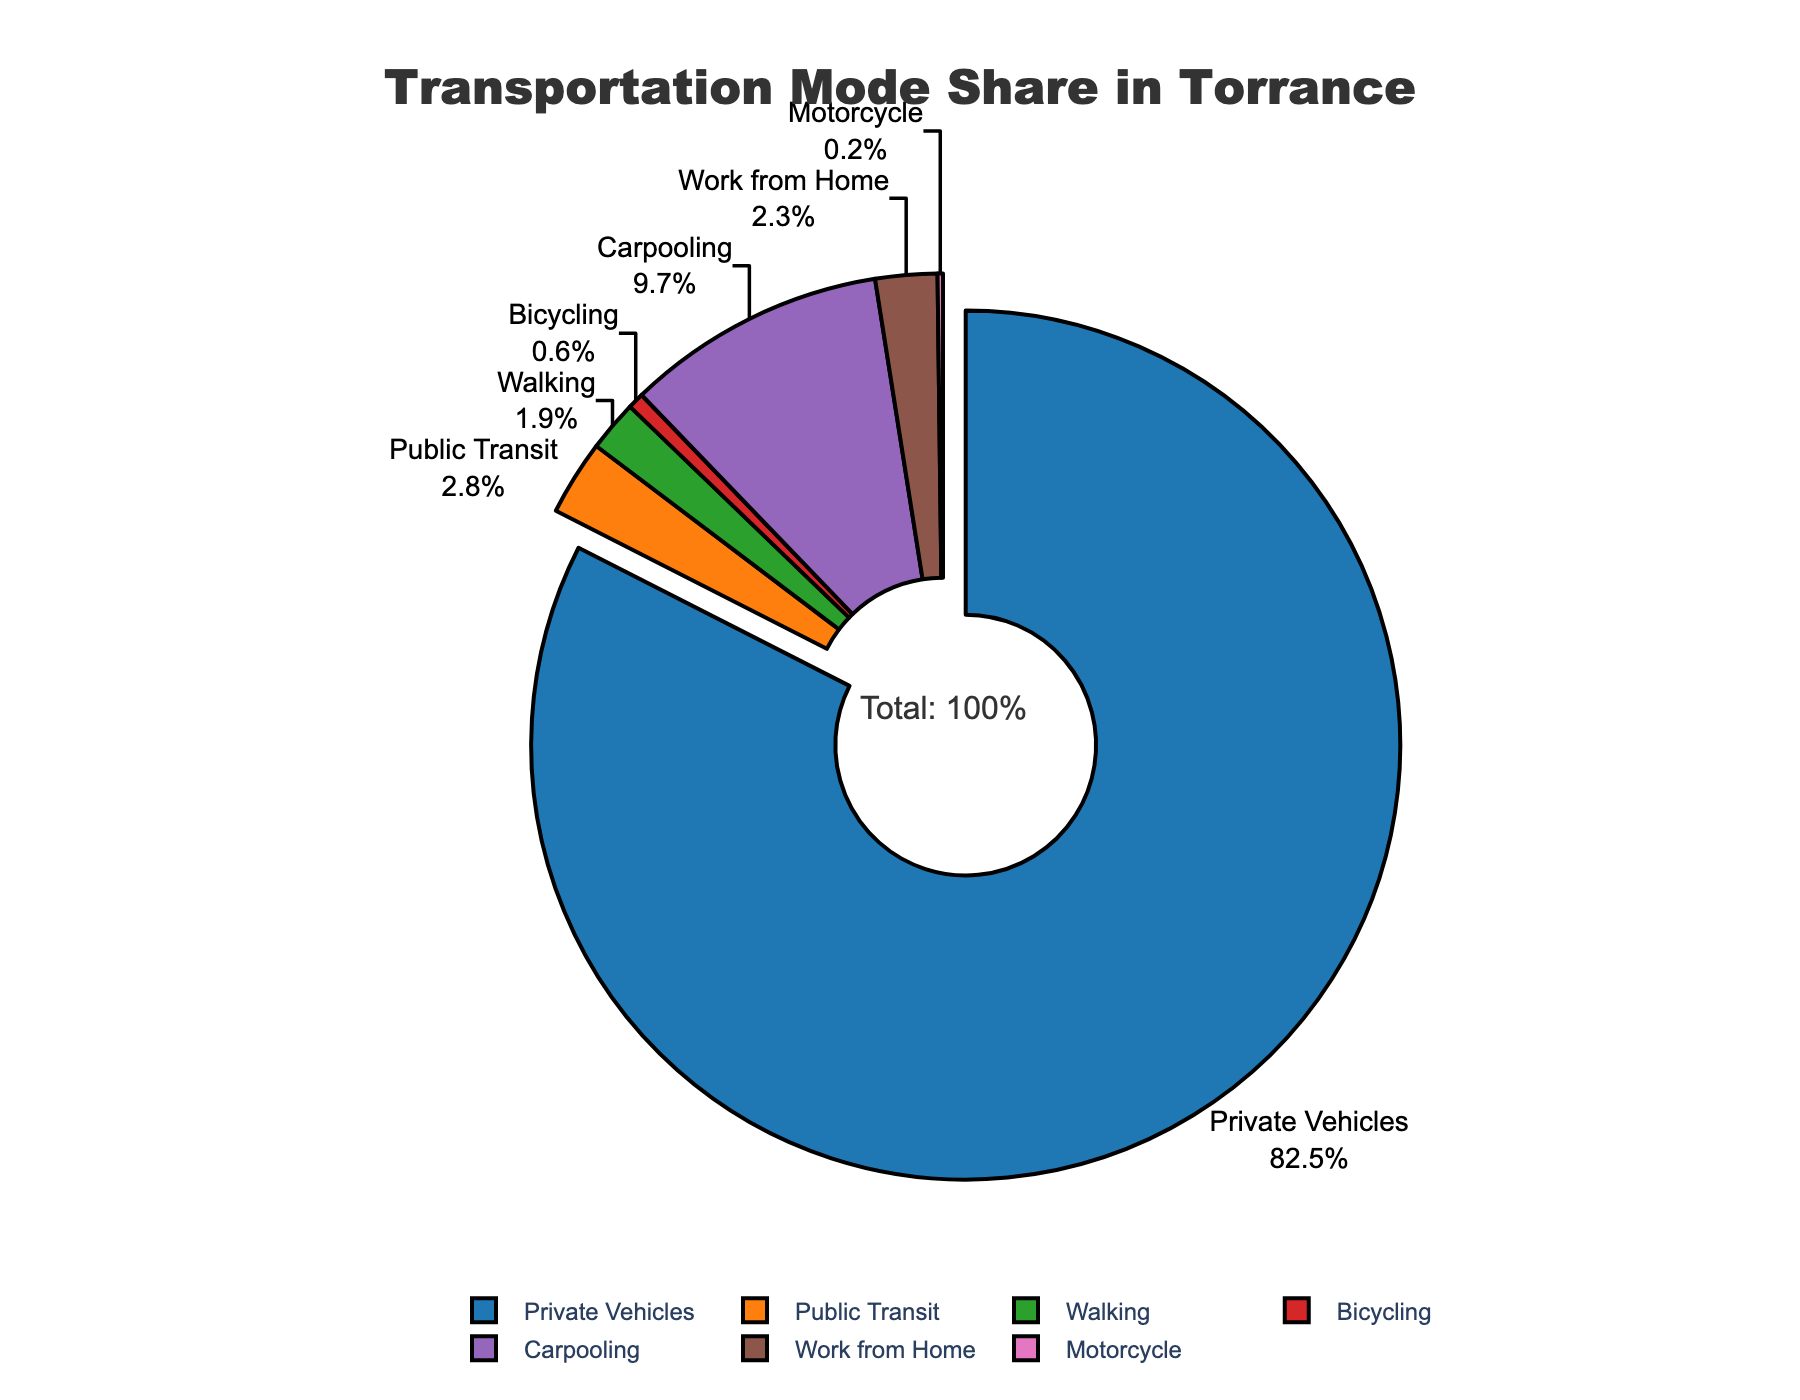What percentage of transportation modes in Torrance is accounted for by private vehicles? The section labeled "Private Vehicles" on the pie chart shows an 82.5% share.
Answer: 82.5% What is the difference in percentage between private vehicles and carpooling? The private vehicles mode is 82.5%, and carpooling is 9.7%. The difference is 82.5% - 9.7% = 72.8%.
Answer: 72.8% Which transportation mode has the smallest share, and what is its percentage? Looking at the pie chart, the "Motorcycle" section is the smallest at 0.2%.
Answer: Motorcycle, 0.2% What is the total percentage of active transport modes (walking and bicycling)? The "Walking" mode has 1.9%, and "Bicycling" has 0.6%. Their total is 1.9% + 0.6% = 2.5%.
Answer: 2.5% Among the non-driving modes, which one has the highest representation? The chart shows "Carpooling" at 9.7%, "Public Transit" at 2.8%, "Walking" at 1.9%, "Bicycling" at 0.6%, and "Motorcycle" at 0.2%. The highest is "Carpooling" at 9.7%.
Answer: Carpooling, 9.7% How many times greater is the percentage of private vehicles compared to public transit? The "Private Vehicles" mode is 82.5%, and "Public Transit" is 2.8%. The ratio is 82.5% / 2.8% = 29.46, so it's 29.46 times greater.
Answer: 29.46 times What is the combined percentage of modes other than private vehicles? Adding percentages of all modes except "Private Vehicles" (82.5%) gives: 2.8% + 1.9% + 0.6% + 9.7% + 2.3% + 0.2% = 17.5%.
Answer: 17.5% What percentage of people work from home according to this chart? The section labeled "Work from Home" shows a 2.3% share.
Answer: 2.3% Is the percentage of people using public transit greater or lesser than those working from home? The "Public Transit" mode is 2.8%, and "Work from Home" is 2.3%. 2.8% > 2.3%, so it's greater.
Answer: Greater Which category has a section larger than the green one representing it visually on the pie chart? By examining the colors, the green color represents "Bicycling" at 0.6%. All sections except "Motorcycle" (0.2%) and "Walking" (1.9%) are visually larger.
Answer: Public Transit, Carpooling, Private Vehicles, Work from Home 